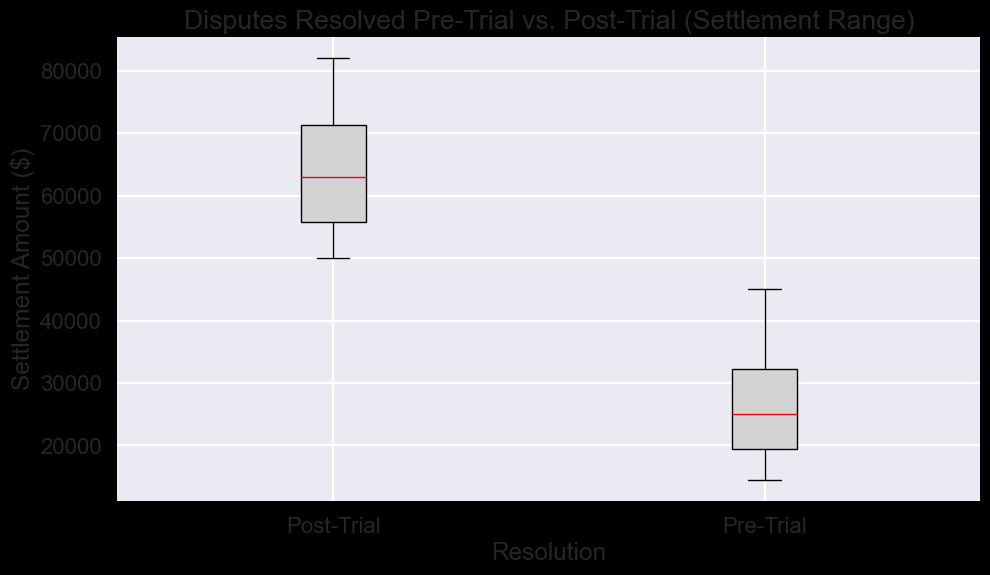What is the median settlement amount for Pre-Trial resolutions? The median is the middle value in a sorted list of numbers. For Pre-Trial resolutions, the settlements in ascending order are: 14500, 15000, 16000, 17000, 18000, 20000, 20000, 22000, 22500, 25000, 25000, 25000, 28500, 30000, 31000, 32000, 33000, 35000, 36000, 40000, 45000. The median value is the middle one, which is 25000.
Answer: 25000 Which resolution type has a higher maximum settlement amount? The box plot shows the whiskers extending to the maximum settlement amounts. The maximum settlement for Pre-Trial is 45000, while for Post-Trial it is 82000. Therefore, Post-Trial has a higher maximum settlement amount.
Answer: Post-Trial How does the interquartile range (IQR) compare between Pre-Trial and Post-Trial resolutions? The IQR is the range between the first quartile (Q1) and the third quartile (Q3). For Pre-Trial, Q1 is around 18500 and Q3 is around 33000, making the IQR 33000 - 18500 = 14500. For Post-Trial, Q1 is around 52000 and Q3 is around 72000, making the IQR 72000 - 52000 = 20000. Comparing these, the IQR for Post-Trial resolutions is larger.
Answer: Post-Trial has a larger IQR Which resolution type has a more significant variation in settlement amounts? Variation in settlement amounts can be assessed by the spread of the data points, which is shown by the length of the box and the whiskers in the box plot. Post-Trial has a longer box and whiskers compared to Pre-Trial, indicating greater variation.
Answer: Post-Trial What is the approximate difference in the median settlement amounts between Pre-Trial and Post-Trial resolutions? The median for Pre-Trial is around 25000, and for Post-Trial it is around 61500. The difference is 61500 - 25000 = 36500.
Answer: 36500 What are the minimum settlement amounts for Pre-Trial and Post-Trial resolutions, and which one is higher? The minimum settlement is indicated by the lower whisker. For Pre-Trial, the minimum is 14500, and for Post-Trial, it is 50000. Therefore, Post-Trial has a higher minimum settlement amount.
Answer: Post-Trial In terms of the overall distribution, which resolution type appears to have more outliers, and how can you tell? Outliers are represented by individual points outside the whiskers in a box plot. The plot should show more blue points (representing outliers) in the Pre-Trial resolution.
Answer: Pre-Trial Which resolution type has a higher upper quartile (Q3) settlement amount, and what is it approximately? The upper quartile (Q3) is the top edge of the box. For Pre-Trial, Q3 is around 33000, and for Post-Trial, Q3 is around 72000. Thus, Post-Trial has a higher Q3 settlement amount.
Answer: Post-Trial, approximately 72000 